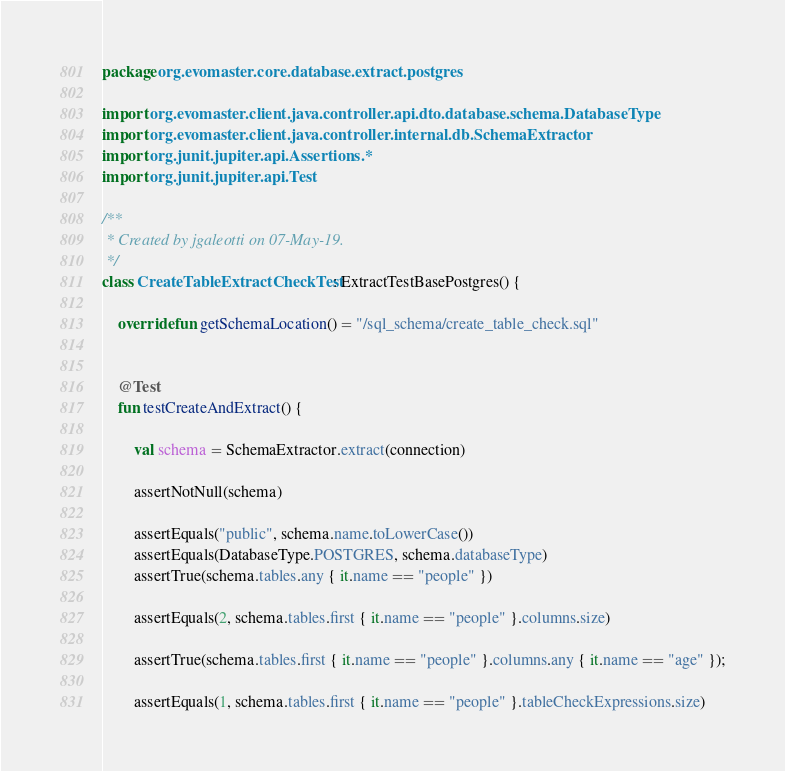Convert code to text. <code><loc_0><loc_0><loc_500><loc_500><_Kotlin_>package org.evomaster.core.database.extract.postgres

import org.evomaster.client.java.controller.api.dto.database.schema.DatabaseType
import org.evomaster.client.java.controller.internal.db.SchemaExtractor
import org.junit.jupiter.api.Assertions.*
import org.junit.jupiter.api.Test

/**
 * Created by jgaleotti on 07-May-19.
 */
class CreateTableExtractCheckTest : ExtractTestBasePostgres() {

    override fun getSchemaLocation() = "/sql_schema/create_table_check.sql"


    @Test
    fun testCreateAndExtract() {

        val schema = SchemaExtractor.extract(connection)

        assertNotNull(schema)

        assertEquals("public", schema.name.toLowerCase())
        assertEquals(DatabaseType.POSTGRES, schema.databaseType)
        assertTrue(schema.tables.any { it.name == "people" })

        assertEquals(2, schema.tables.first { it.name == "people" }.columns.size)

        assertTrue(schema.tables.first { it.name == "people" }.columns.any { it.name == "age" });

        assertEquals(1, schema.tables.first { it.name == "people" }.tableCheckExpressions.size)</code> 